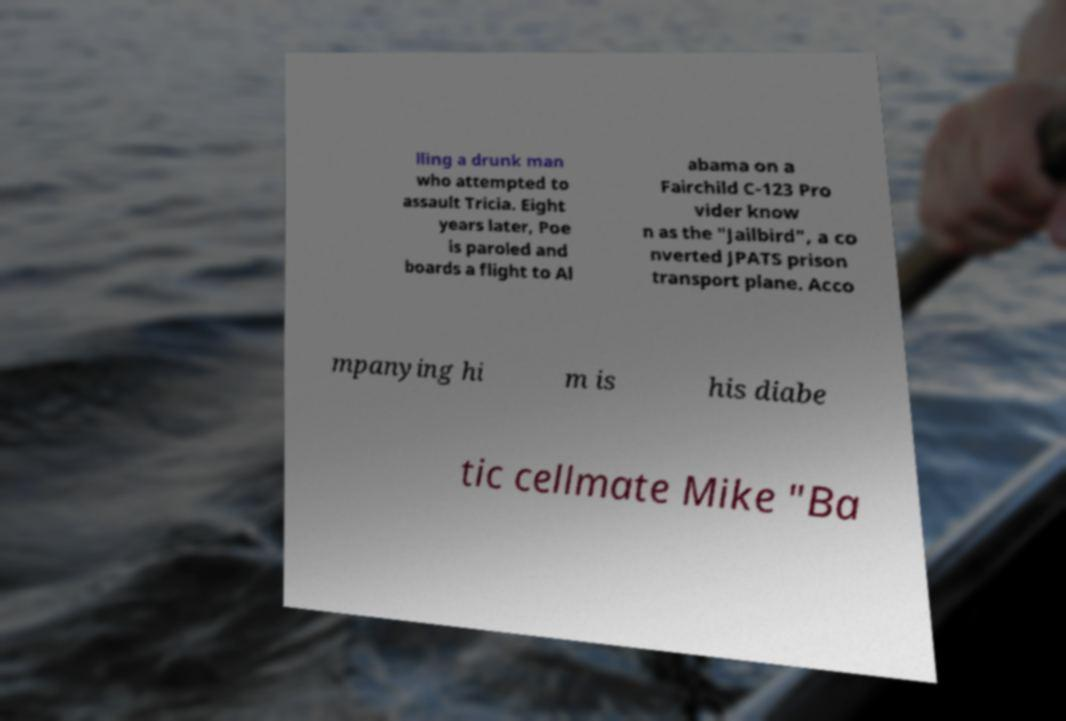For documentation purposes, I need the text within this image transcribed. Could you provide that? lling a drunk man who attempted to assault Tricia. Eight years later, Poe is paroled and boards a flight to Al abama on a Fairchild C-123 Pro vider know n as the "Jailbird", a co nverted JPATS prison transport plane. Acco mpanying hi m is his diabe tic cellmate Mike "Ba 